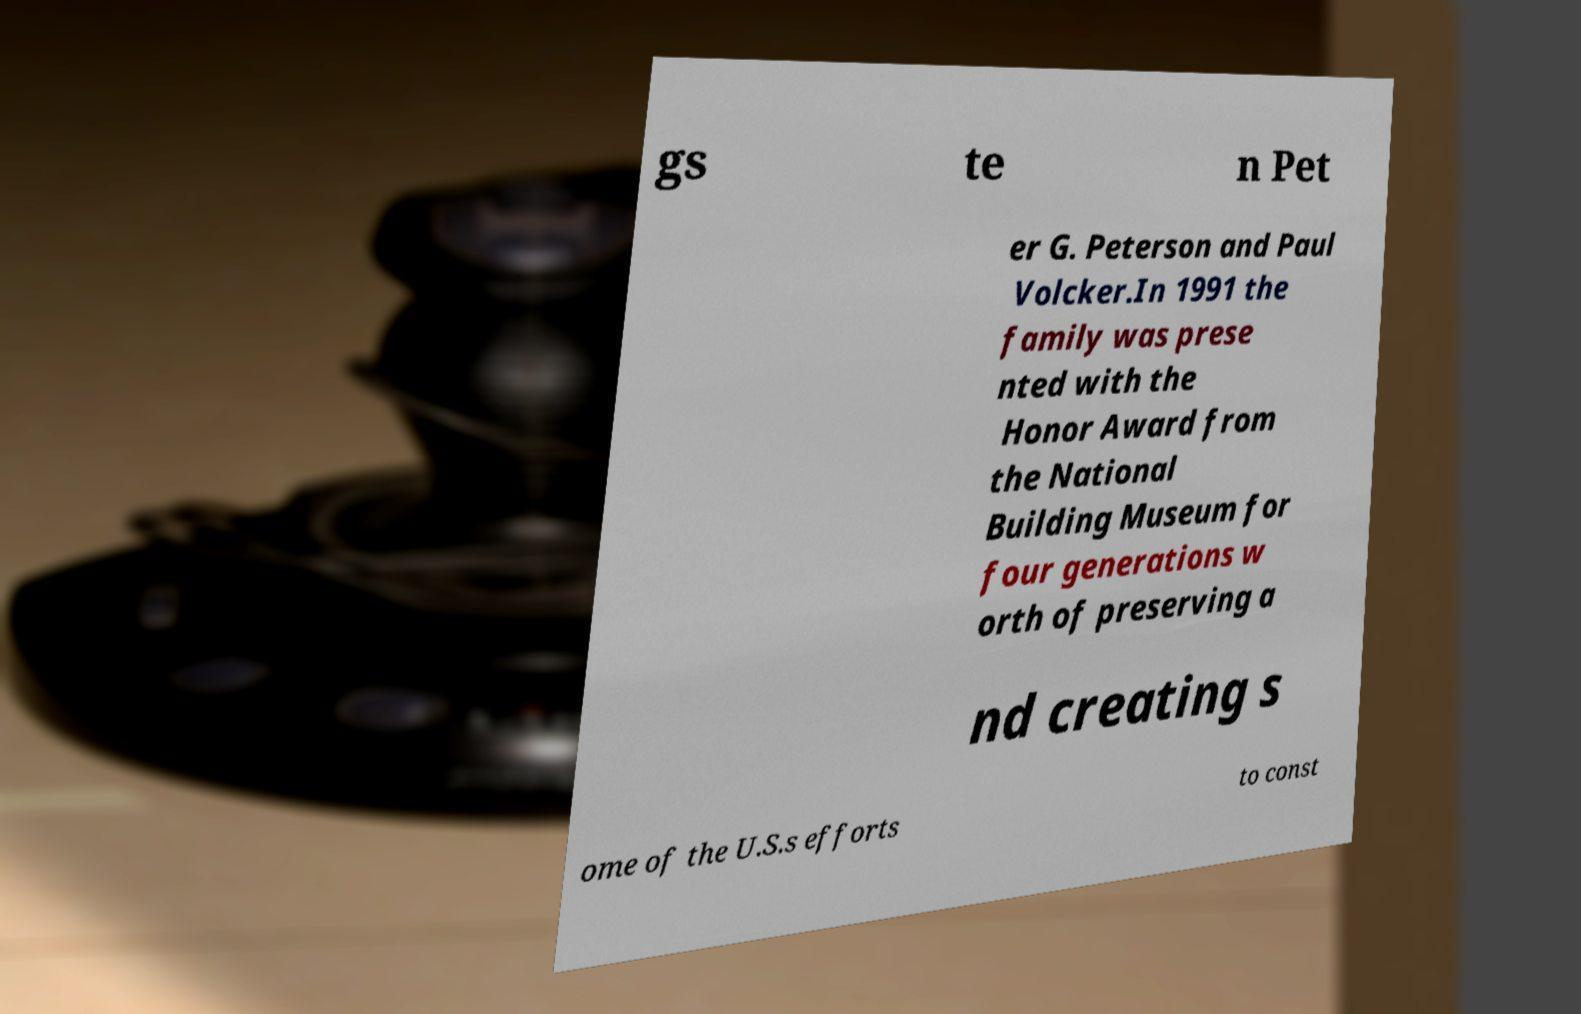I need the written content from this picture converted into text. Can you do that? gs te n Pet er G. Peterson and Paul Volcker.In 1991 the family was prese nted with the Honor Award from the National Building Museum for four generations w orth of preserving a nd creating s ome of the U.S.s efforts to const 